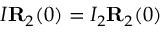Convert formula to latex. <formula><loc_0><loc_0><loc_500><loc_500>I { R } _ { 2 } ( 0 ) = I _ { 2 } { R } _ { 2 } ( 0 )</formula> 